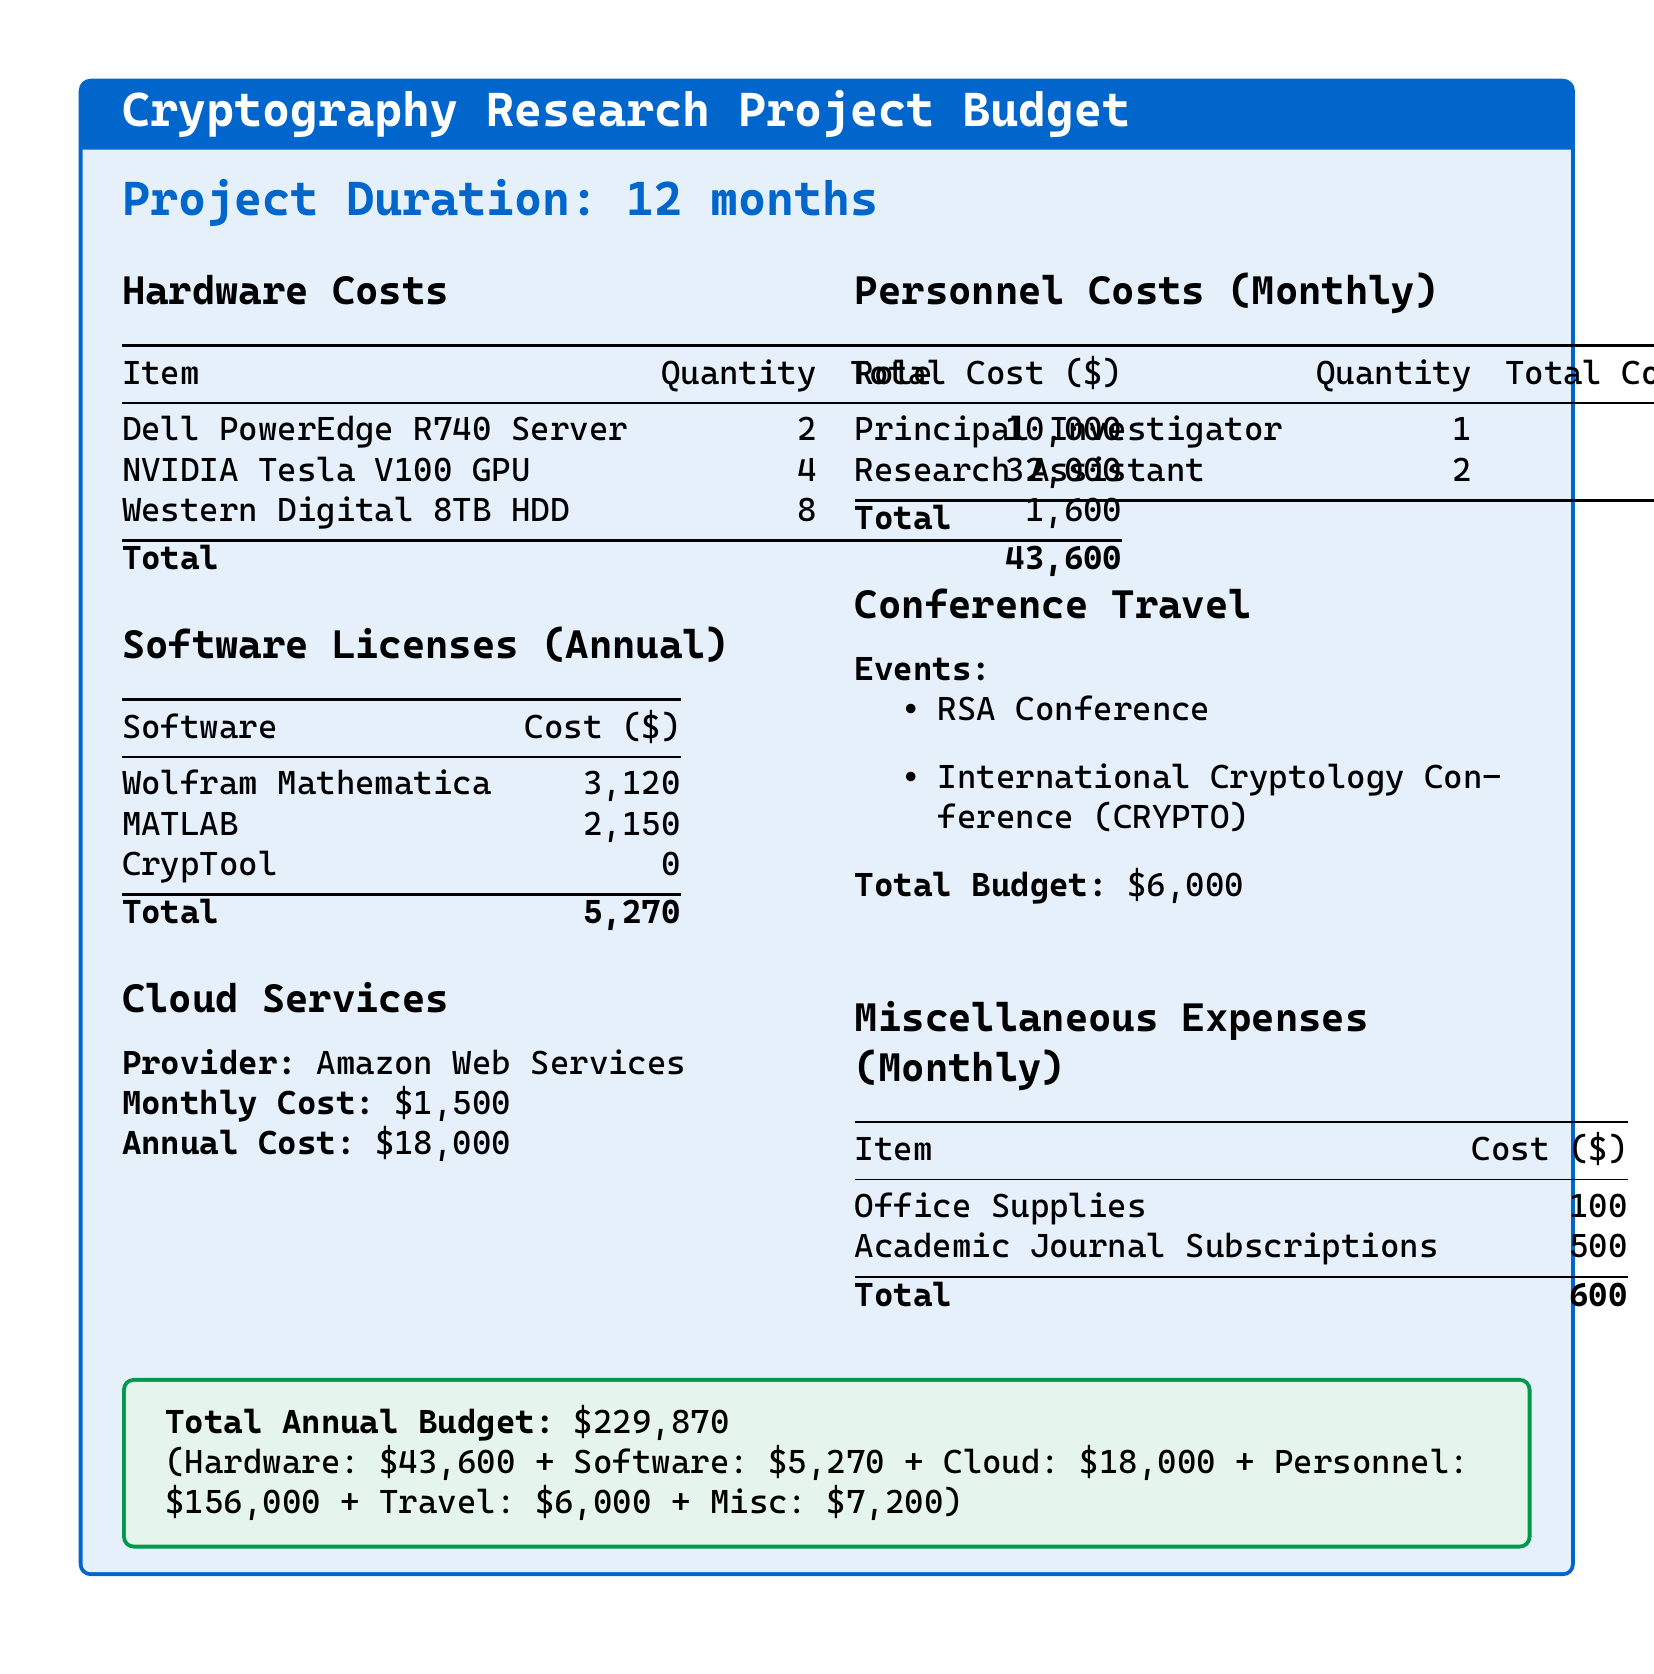What is the total cost of hardware? The total cost of hardware is listed at the bottom of the hardware costs section, which is $43,600.
Answer: $43,600 How many NVIDIA Tesla V100 GPUs are included? The document states that there are 4 NVIDIA Tesla V100 GPUs listed under hardware costs.
Answer: 4 What is the monthly cost for cloud services? The monthly cost for cloud services is mentioned to be $1,500.
Answer: $1,500 What is the total budget allocated for conference travel? The total budget for conference travel is specified as $6,000 in the document.
Answer: $6,000 What is the personnel cost per month for the Principal Investigator? The personnel cost for the Principal Investigator is listed as $8,000 per month in the document.
Answer: $8,000 How much are the annual software licenses in total? The document shows the total for annual software licenses at $5,270 at the bottom of the software licenses section.
Answer: $5,270 What is the total annual budget for the project? The total annual budget is stated at the end of the document as $229,870.
Answer: $229,870 What is the total cost for miscellaneous monthly expenses? The total for miscellaneous monthly expenses is $600 provided in the miscellaneous expenses section.
Answer: $600 How many Research Assistants are included in personnel costs? The document specifies that there are 2 Research Assistants included in the personnel costs.
Answer: 2 